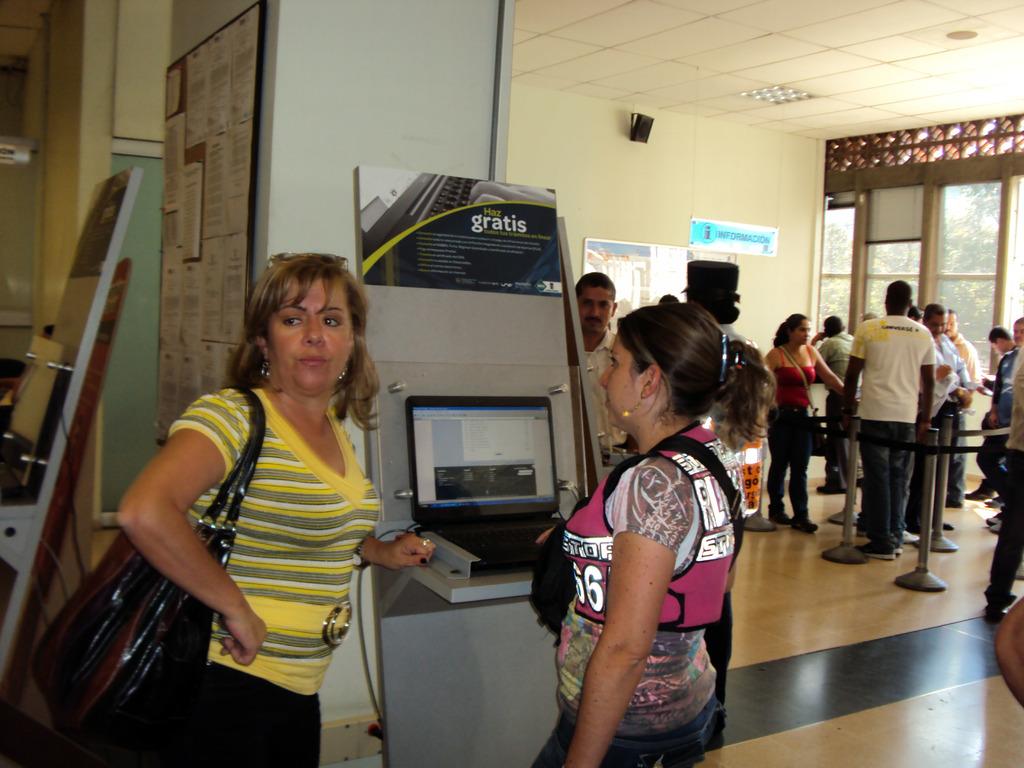What word is written in white on the panel above the computer screen?
Your answer should be very brief. Gratis. 